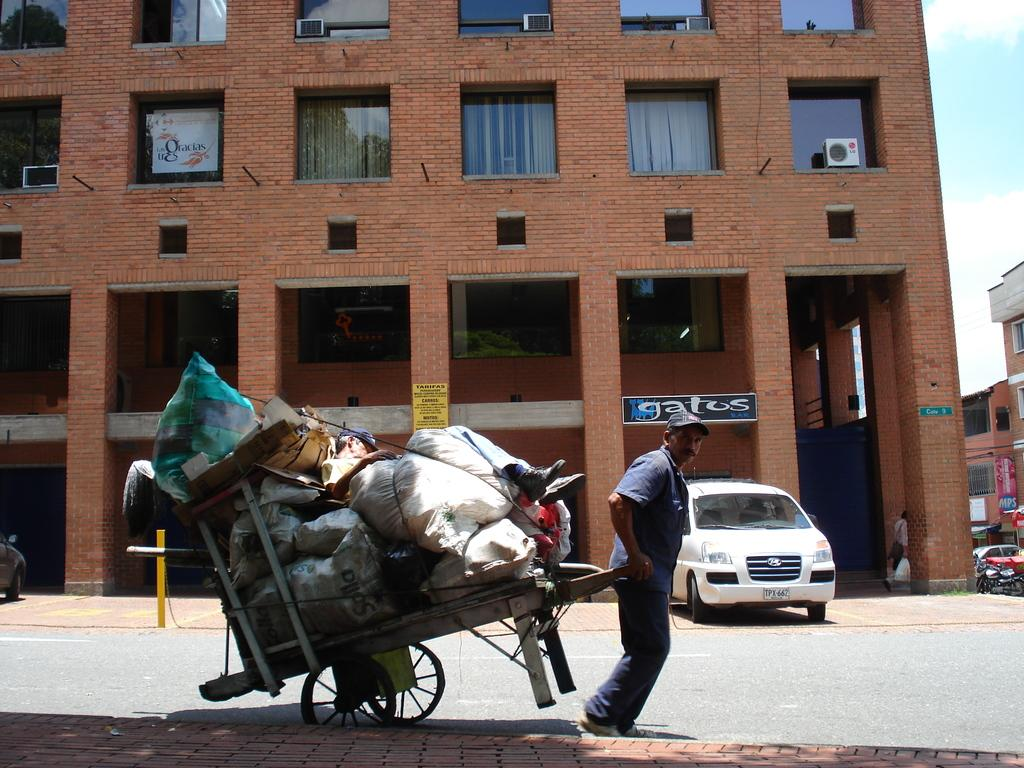Who is present in the image? There is a person in the image. What is the person wearing? The person is wearing clothes. What is the person doing in the image? The person is pulling a handcart. What can be seen in front of a building in the image? There is a car in front of a building. What part of the sky is visible in the image? The sky is visible in the top right of the image. What type of camera is the person holding in the image? There is no camera present in the image; the person is pulling a handcart. How many men are visible in the image? The image only shows one person, who is not explicitly identified as a man. 